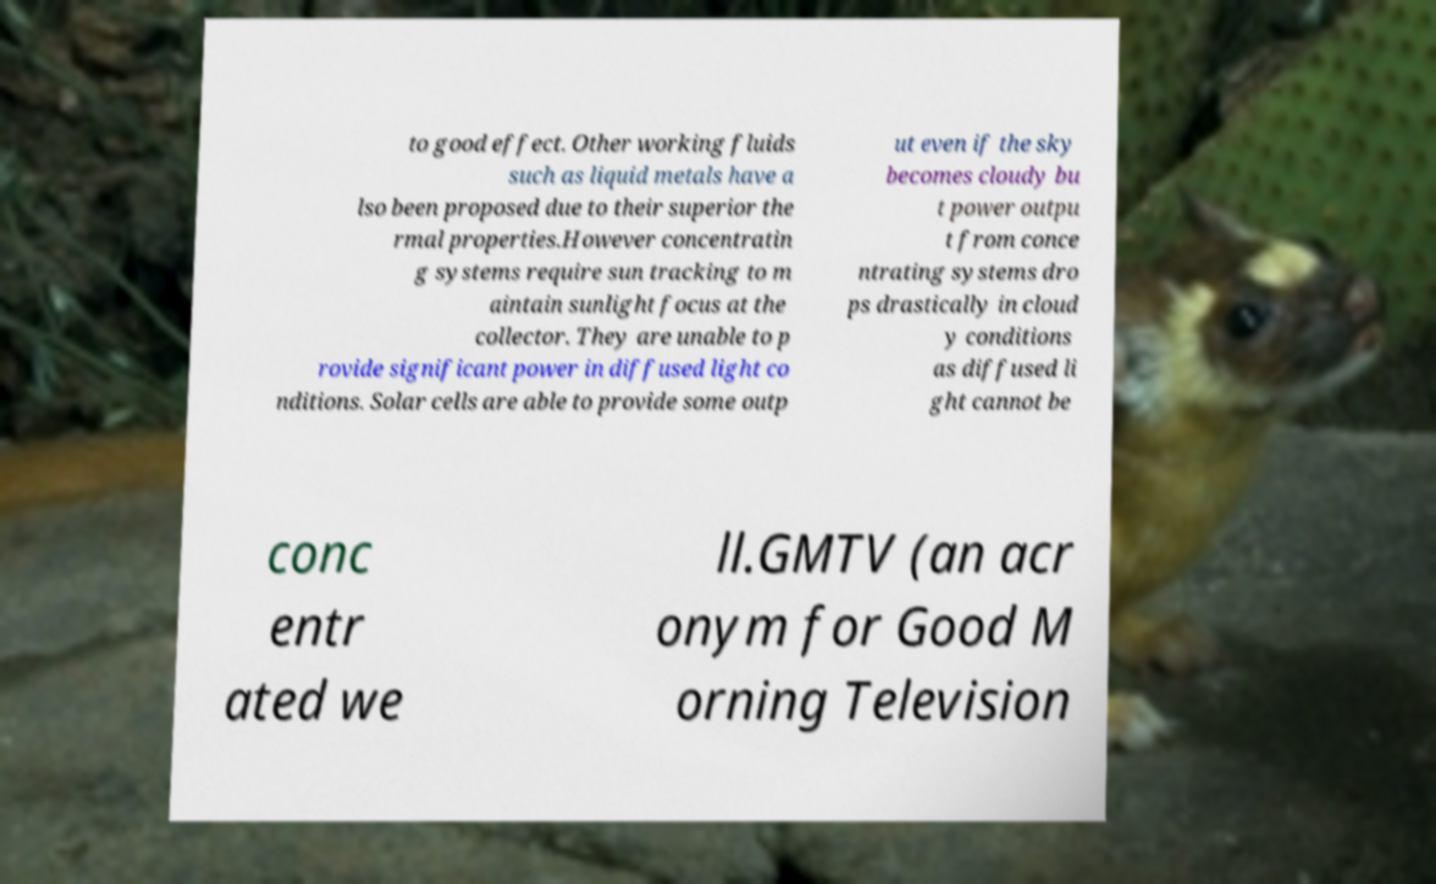Please read and relay the text visible in this image. What does it say? to good effect. Other working fluids such as liquid metals have a lso been proposed due to their superior the rmal properties.However concentratin g systems require sun tracking to m aintain sunlight focus at the collector. They are unable to p rovide significant power in diffused light co nditions. Solar cells are able to provide some outp ut even if the sky becomes cloudy bu t power outpu t from conce ntrating systems dro ps drastically in cloud y conditions as diffused li ght cannot be conc entr ated we ll.GMTV (an acr onym for Good M orning Television 